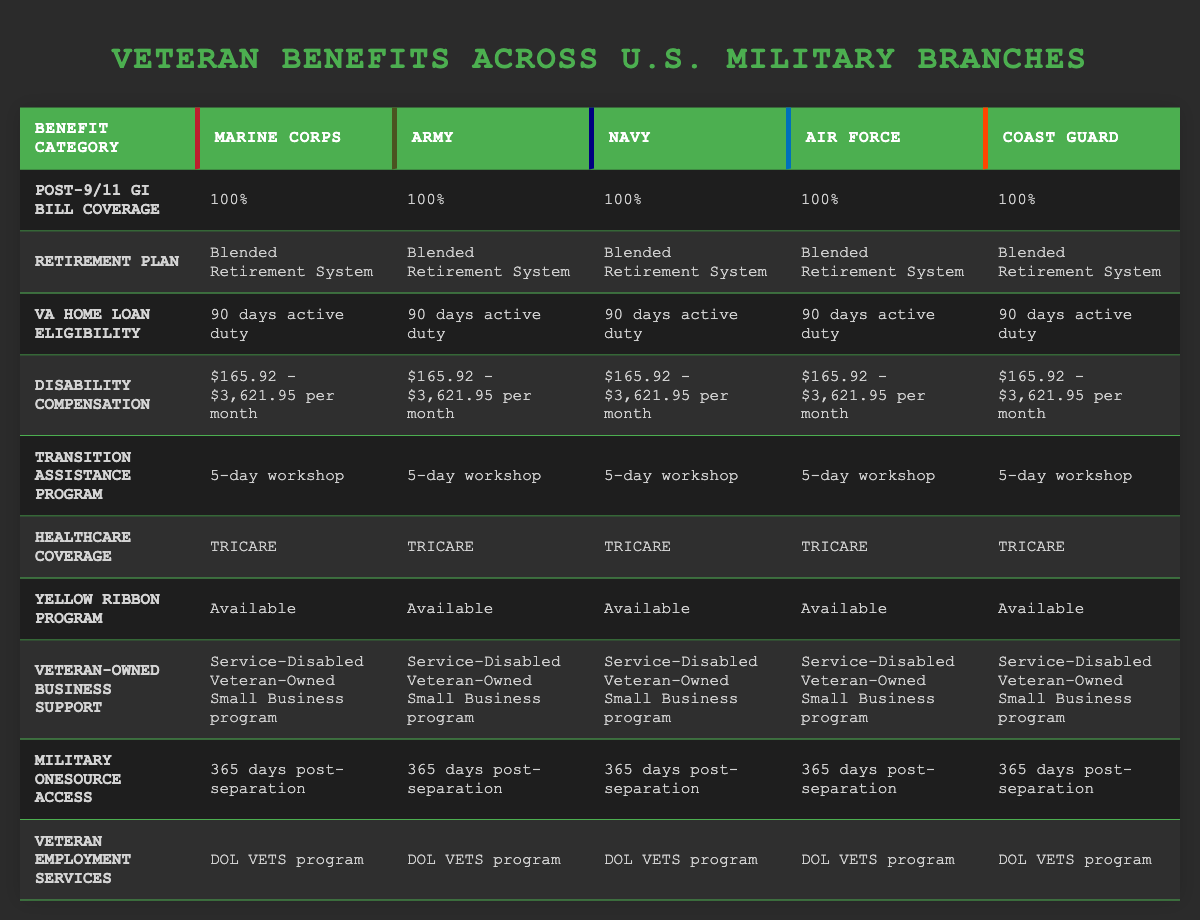What is the healthcare coverage provided to veterans across all branches? All branches provide TRICARE as the healthcare coverage for veterans. This can be confirmed by looking through the Healthcare Coverage row in the table, which lists "TRICARE" for the Marine Corps, Army, Navy, Air Force, and Coast Guard.
Answer: TRICARE Which branches of the military offer a 5-day Transition Assistance Program? The table shows that each branch (Marine Corps, Army, Navy, Air Force, and Coast Guard) has a 5-day workshop for the Transition Assistance Program. This information can be found under the Transition Assistance Program row.
Answer: All branches What is the range of disability compensation across branches? The disability compensation is the same across all branches, with amounts listed as $165.92 - $3,621.95 per month. This is directly seen in the Disability Compensation row, confirming that there is no variation among branches.
Answer: $165.92 - $3,621.95 per month Are there any differences in VA Home Loan eligibility requirements across the branches? No, there are no differences as all branches list the same eligibility requirement of 90 days active duty for VA Home Loan Eligibility. This can be determined by reviewing the VA Home Loan Eligibility row, which provides a uniform answer across all five military branches.
Answer: No If a veteran served in the Marine Corps for 90 days, what benefits under VA Home Loan eligibility would they receive that are specific to their branch? A veteran who served 90 days in the Marine Corps would receive the same VA Home Loan eligibility that all branches provide, which is 90 days active duty. The information in the VA Home Loan Eligibility row indicates that there are no unique benefits that differ by branch if the duration of service is the same.
Answer: 90 days active duty What overarching retirement plan is in place for all branches of the military? The table specifies that all branches offer the Blended Retirement System as the retirement plan. This can be found in the Retirement Plan row where this information is uniform across every military branch.
Answer: Blended Retirement System How long can veterans access Military OneSource post-separation regardless of the branch? Veterans can access Military OneSource for 365 days post-separation. This is indicated in the Military OneSource Access row, where the same duration is stated for all five branches of the military.
Answer: 365 days Does the Yellow Ribbon Program exist for all branches of the military? Yes, the Yellow Ribbon Program is available to veterans from all branches, as stated in the Yellow Ribbon Program row where "Available" is noted for each branch.
Answer: Yes Which benefit does every branch offer to support veteran-owned businesses? All branches support veteran-owned businesses through the Service-Disabled Veteran-Owned Small Business program. This is confirmed in the Veteran-Owned Business Support row, which lists the same program for every branch.
Answer: Service-Disabled Veteran-Owned Small Business program 